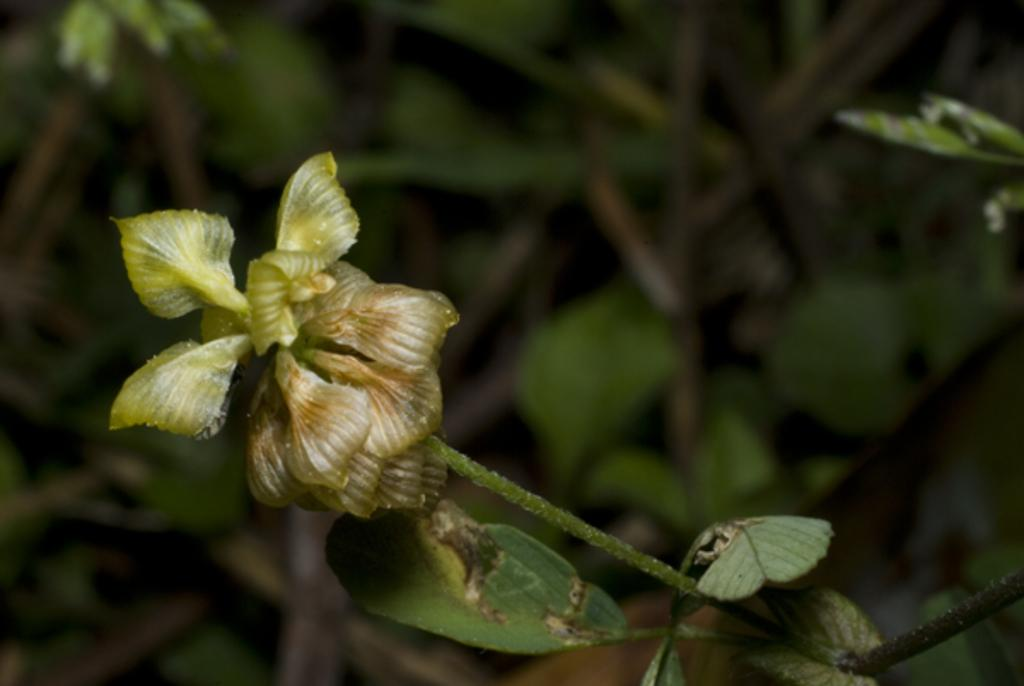What is present in the image? There is a plant in the image. What color is the plant? The plant is green. What color is the background in the image? The background has a black color. Is there a secretary working on a chin in the image? No, there is no secretary or chin present in the image; it only features a green plant against a black background. 